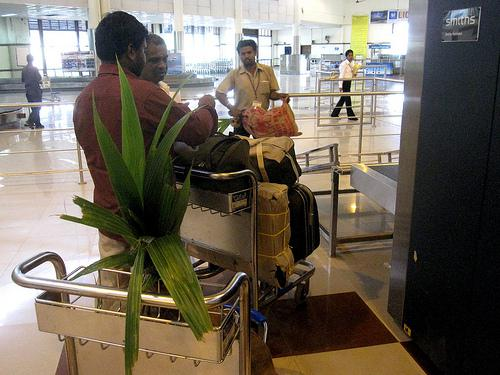Question: where was the picture taken?
Choices:
A. An airport.
B. In the subway.
C. On the Empire state building.
D. Near the grand canyon.
Answer with the letter. Answer: A Question: what color is the cart?
Choices:
A. Red.
B. Black.
C. Dark blue.
D. Silver.
Answer with the letter. Answer: D Question: what is the cart made of?
Choices:
A. Plastic.
B. Metal.
C. Wood.
D. Ceramic.
Answer with the letter. Answer: B 